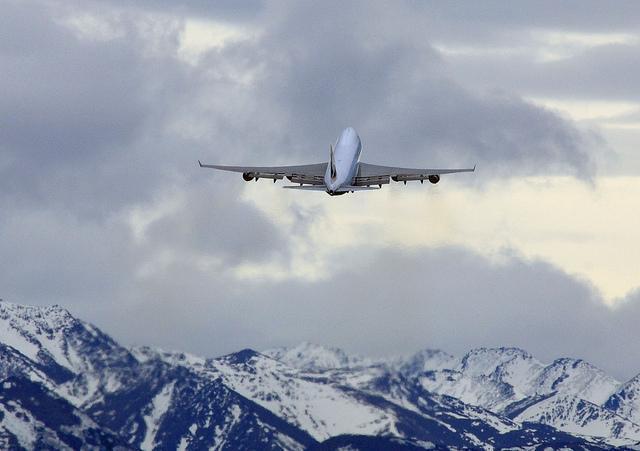How many people are shown?
Give a very brief answer. 0. 